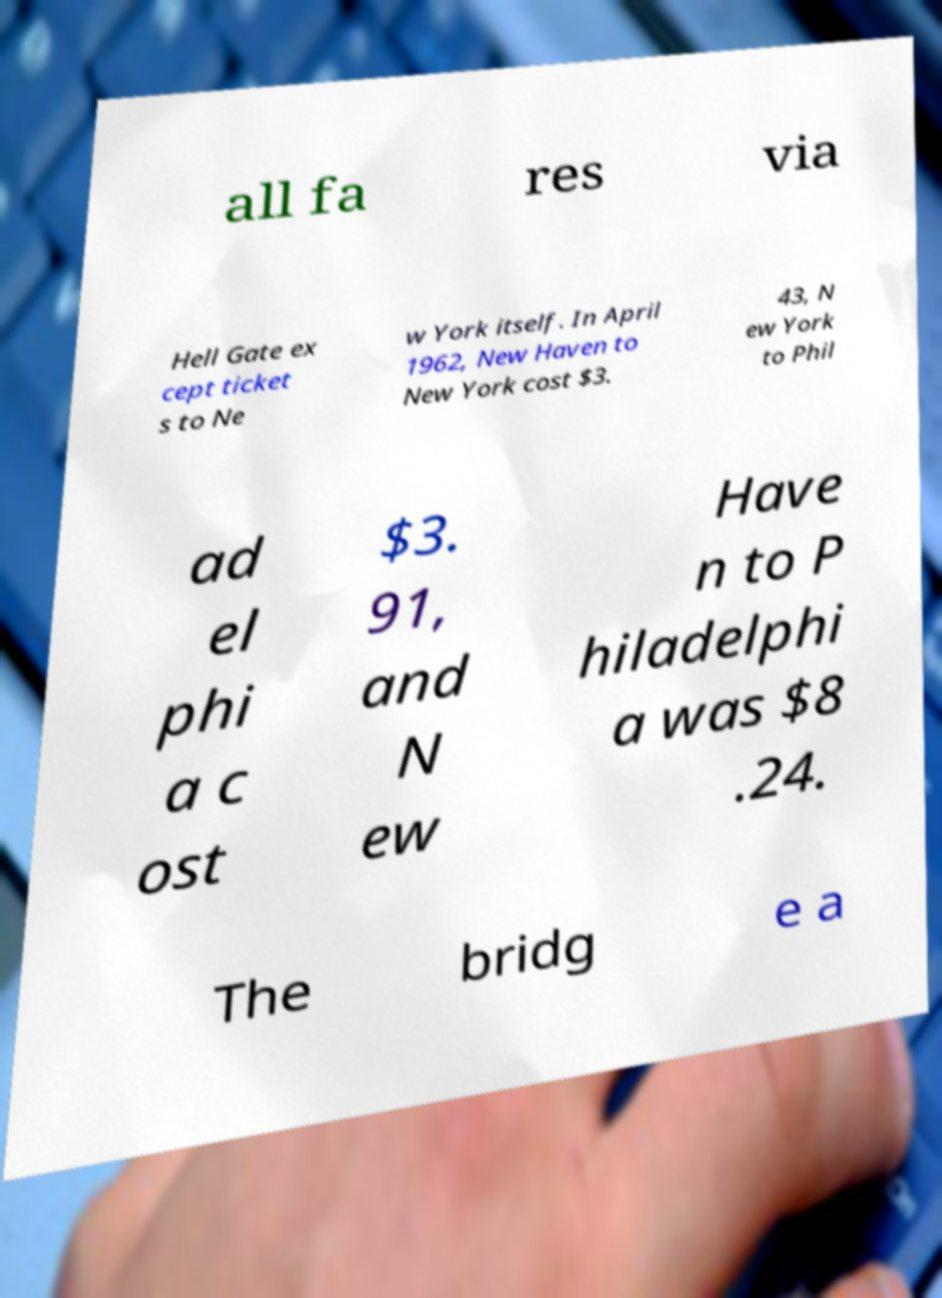I need the written content from this picture converted into text. Can you do that? all fa res via Hell Gate ex cept ticket s to Ne w York itself. In April 1962, New Haven to New York cost $3. 43, N ew York to Phil ad el phi a c ost $3. 91, and N ew Have n to P hiladelphi a was $8 .24. The bridg e a 